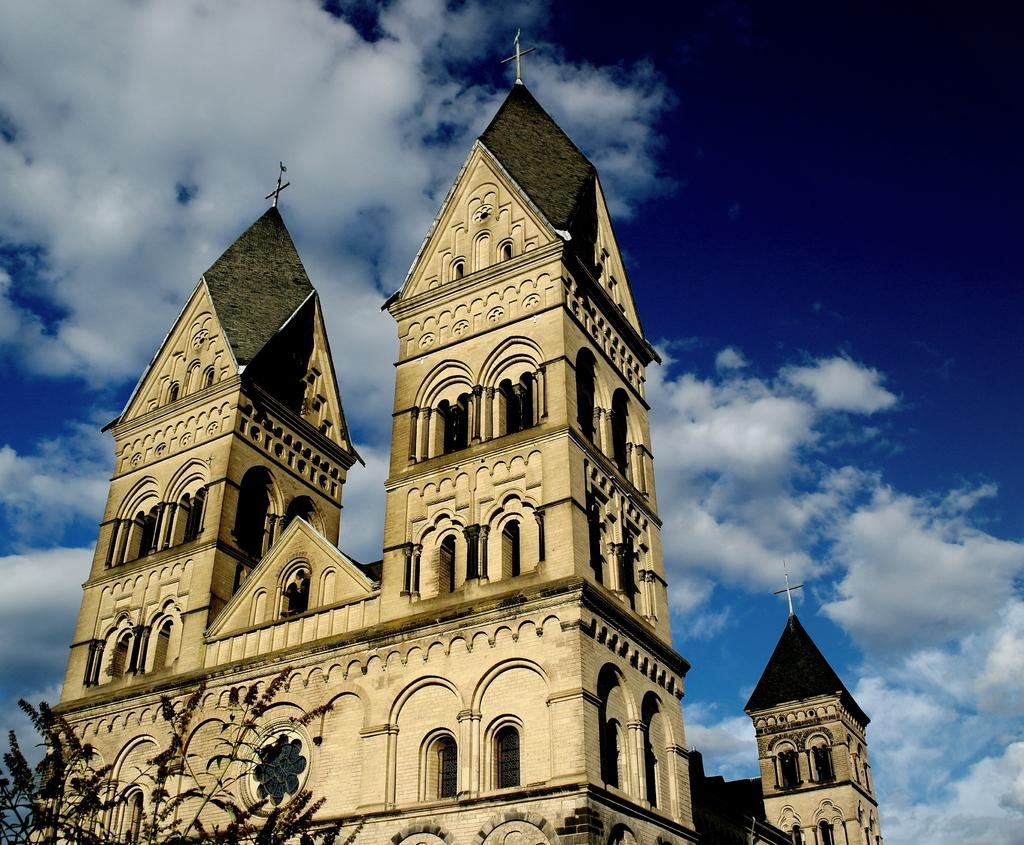What type of structure is present in the image? There is a building in the image. What other natural element can be seen in the image? There is a tree in the image. What color is the sky in the background of the image? The sky is blue in the background of the image. Are there any weather elements visible in the sky? Yes, clouds are visible in the sky. What type of collar can be seen on the tomatoes in the image? There are no tomatoes, nor any collars, present in the image. 